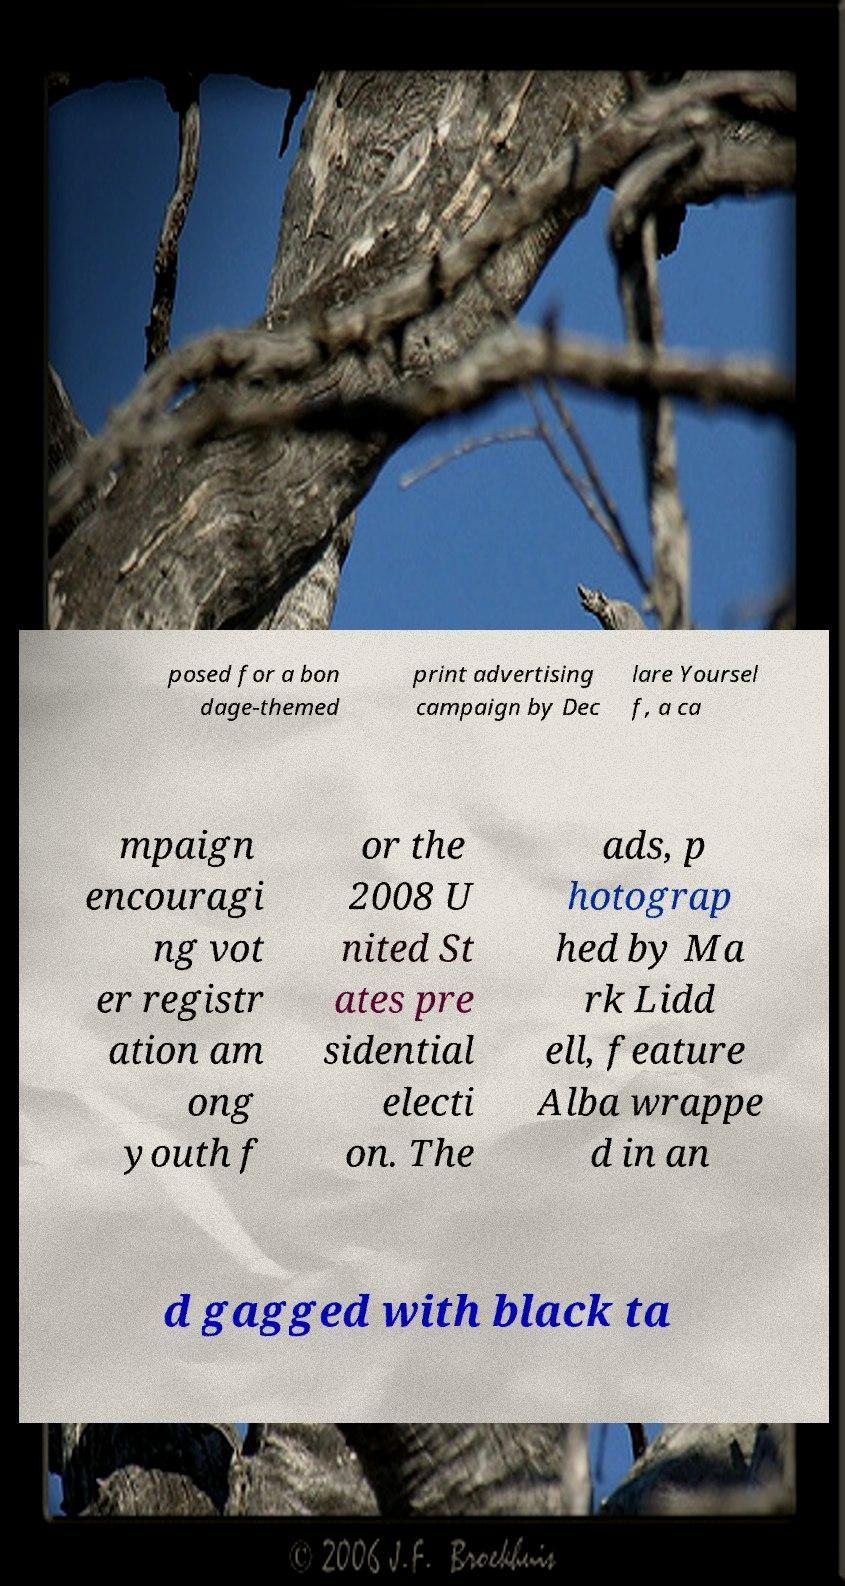Please read and relay the text visible in this image. What does it say? posed for a bon dage-themed print advertising campaign by Dec lare Yoursel f, a ca mpaign encouragi ng vot er registr ation am ong youth f or the 2008 U nited St ates pre sidential electi on. The ads, p hotograp hed by Ma rk Lidd ell, feature Alba wrappe d in an d gagged with black ta 